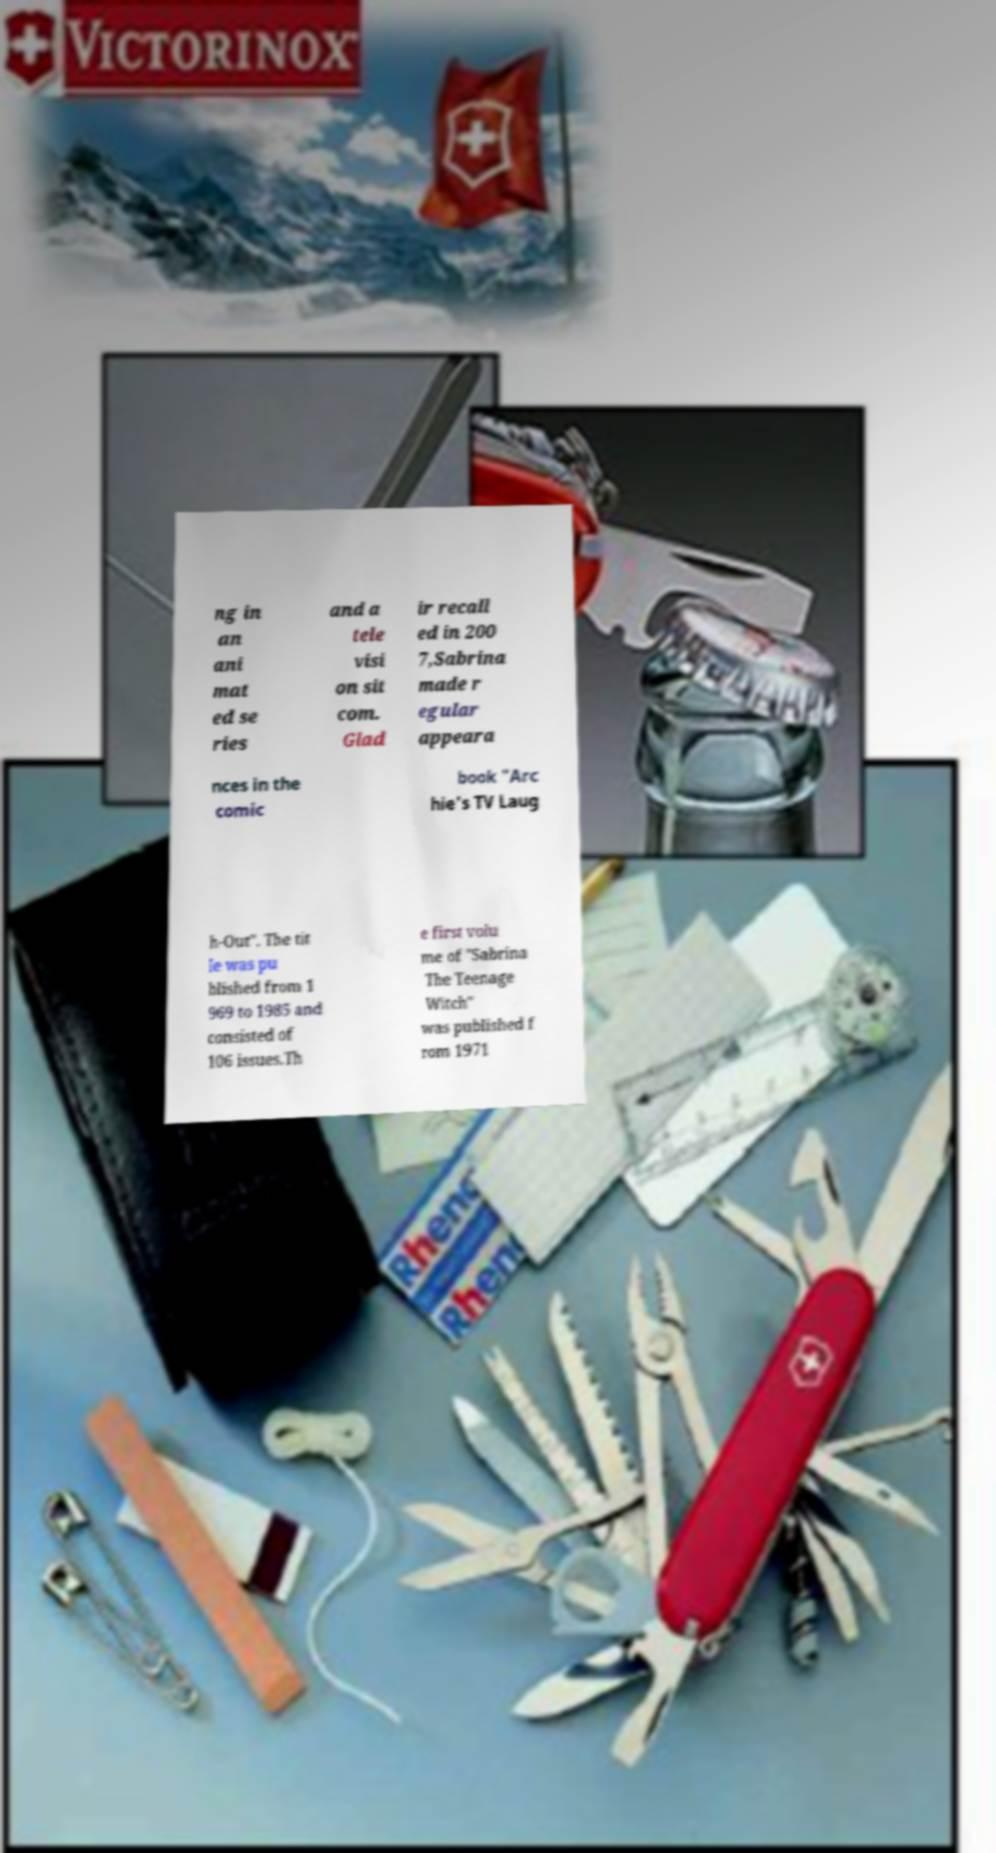Could you extract and type out the text from this image? ng in an ani mat ed se ries and a tele visi on sit com. Glad ir recall ed in 200 7,Sabrina made r egular appeara nces in the comic book "Arc hie's TV Laug h-Out". The tit le was pu blished from 1 969 to 1985 and consisted of 106 issues.Th e first volu me of "Sabrina The Teenage Witch" was published f rom 1971 